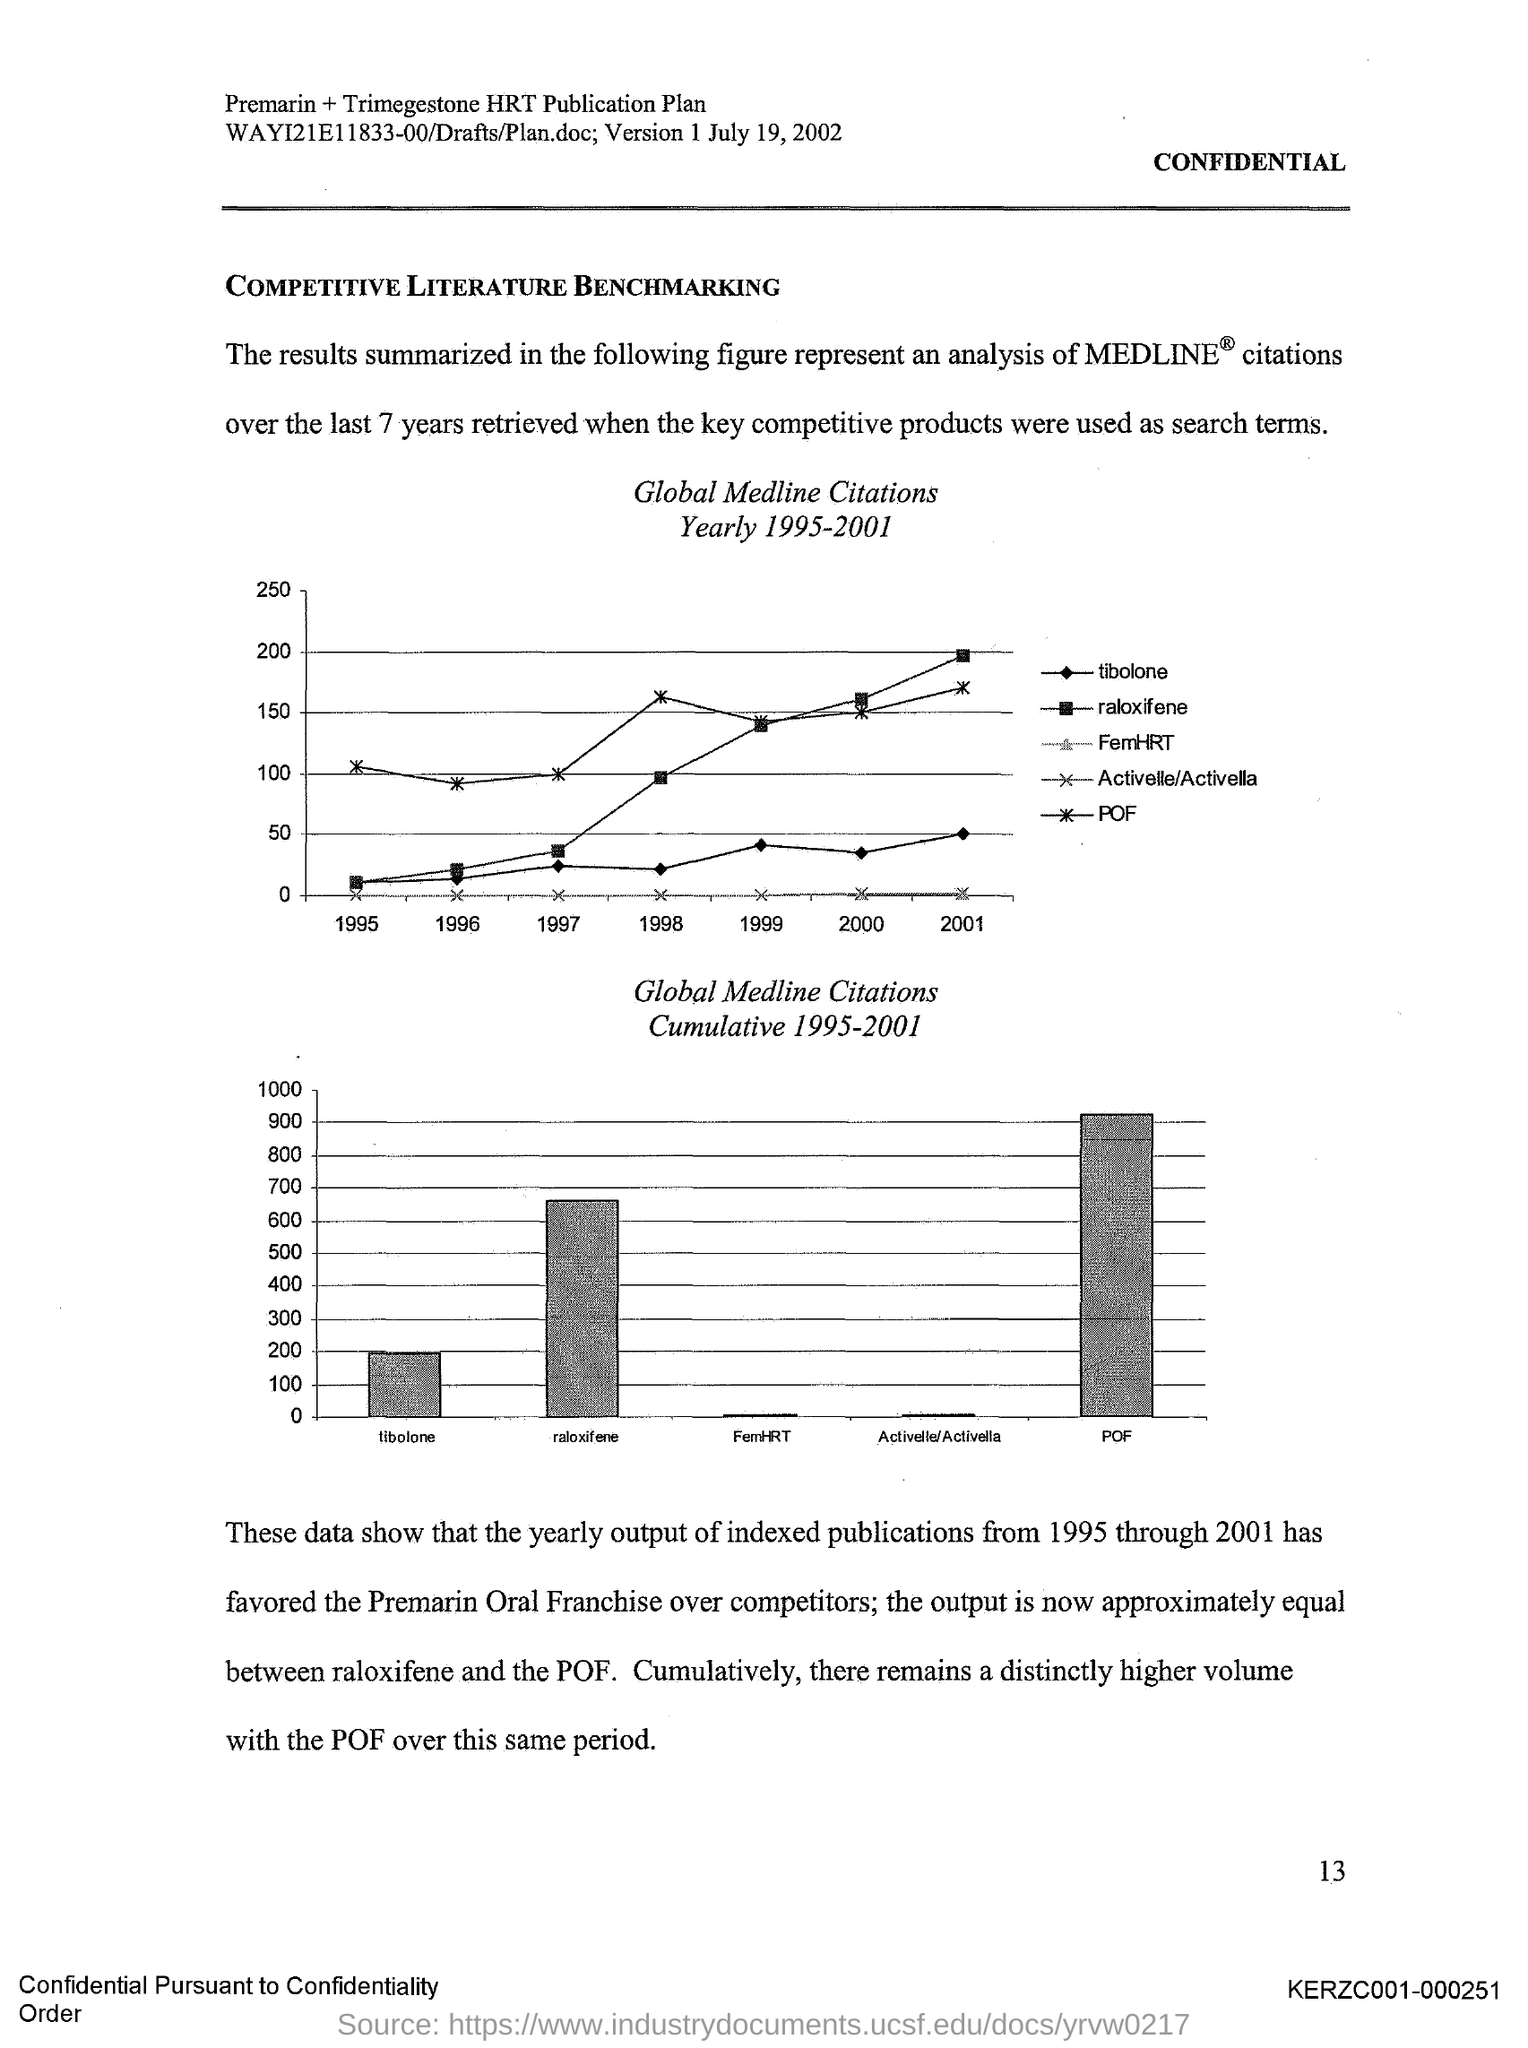What does the results summarized in the figure represent?
Provide a short and direct response. An analysis of medline citations. 